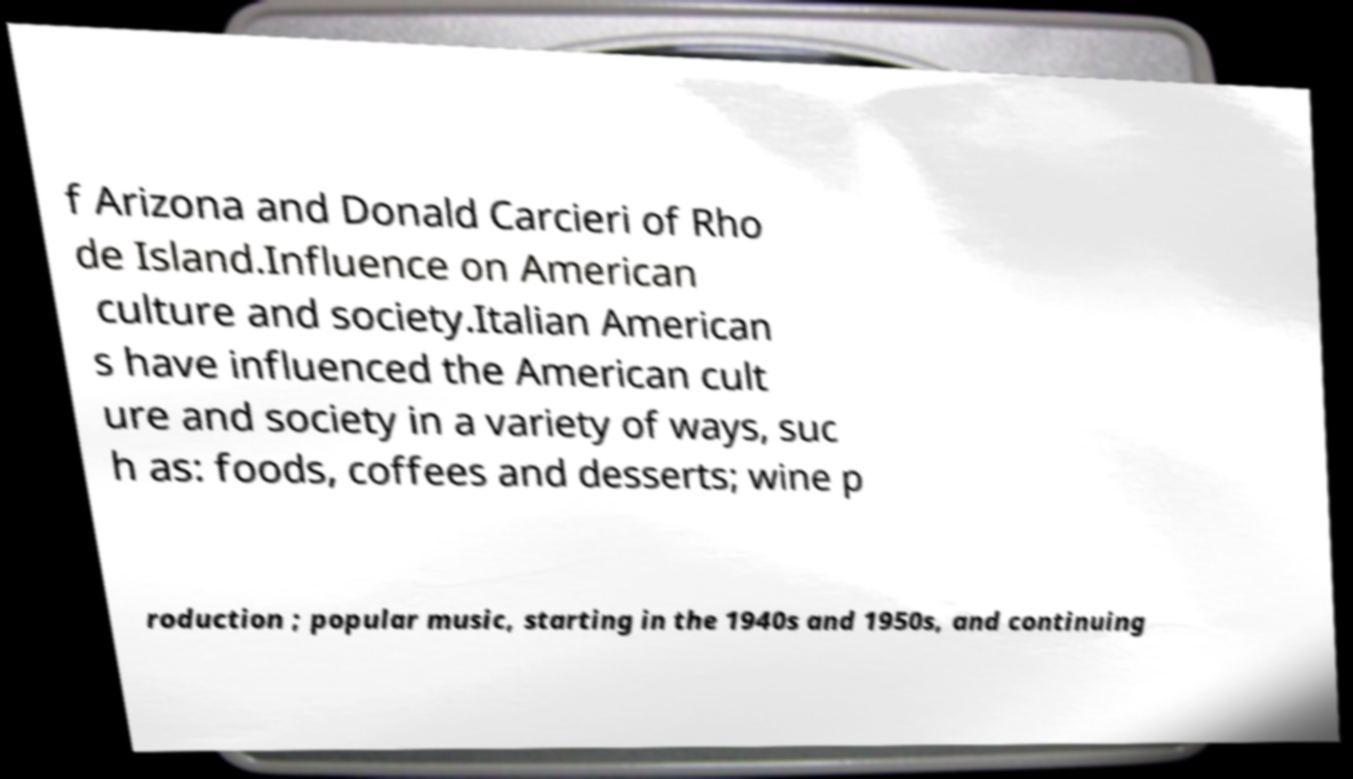Please identify and transcribe the text found in this image. f Arizona and Donald Carcieri of Rho de Island.Influence on American culture and society.Italian American s have influenced the American cult ure and society in a variety of ways, suc h as: foods, coffees and desserts; wine p roduction ; popular music, starting in the 1940s and 1950s, and continuing 